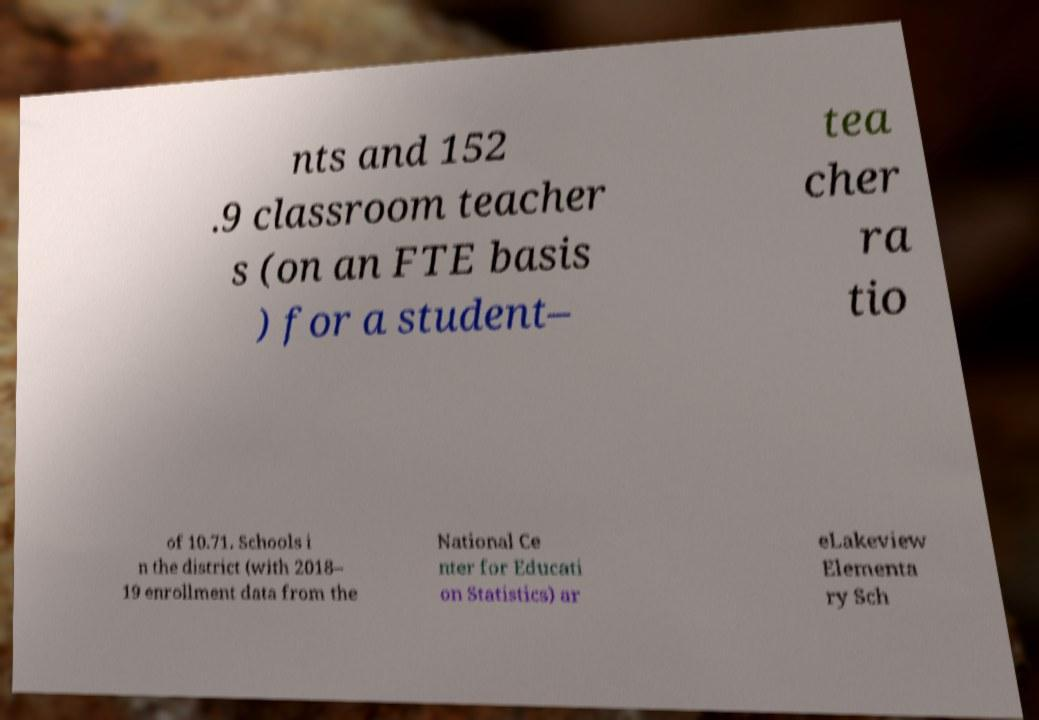Please read and relay the text visible in this image. What does it say? nts and 152 .9 classroom teacher s (on an FTE basis ) for a student– tea cher ra tio of 10.71. Schools i n the district (with 2018– 19 enrollment data from the National Ce nter for Educati on Statistics) ar eLakeview Elementa ry Sch 